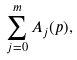<formula> <loc_0><loc_0><loc_500><loc_500>\sum _ { j = 0 } ^ { m } A _ { j } ( p ) ,</formula> 